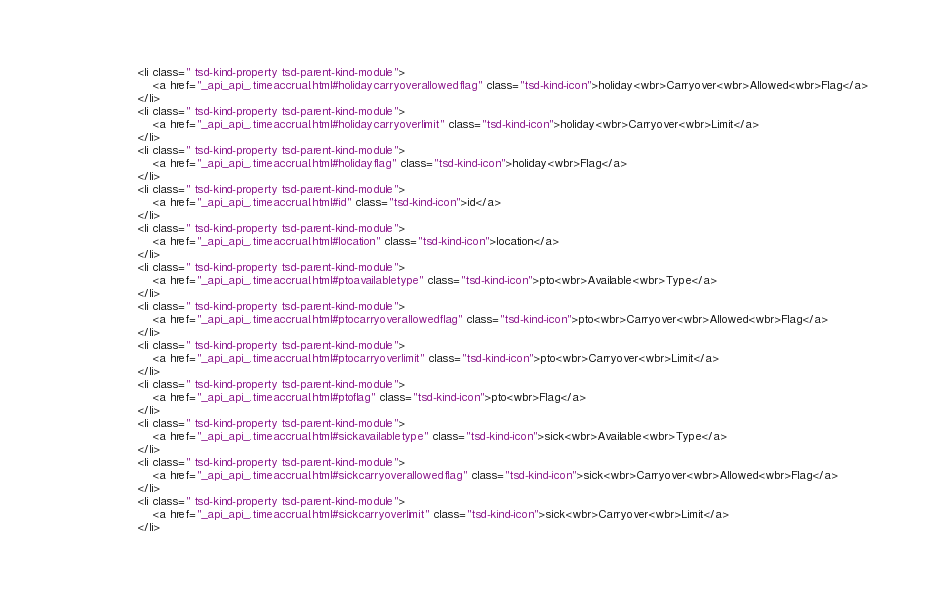Convert code to text. <code><loc_0><loc_0><loc_500><loc_500><_HTML_>					<li class=" tsd-kind-property tsd-parent-kind-module">
						<a href="_api_api_.timeaccrual.html#holidaycarryoverallowedflag" class="tsd-kind-icon">holiday<wbr>Carryover<wbr>Allowed<wbr>Flag</a>
					</li>
					<li class=" tsd-kind-property tsd-parent-kind-module">
						<a href="_api_api_.timeaccrual.html#holidaycarryoverlimit" class="tsd-kind-icon">holiday<wbr>Carryover<wbr>Limit</a>
					</li>
					<li class=" tsd-kind-property tsd-parent-kind-module">
						<a href="_api_api_.timeaccrual.html#holidayflag" class="tsd-kind-icon">holiday<wbr>Flag</a>
					</li>
					<li class=" tsd-kind-property tsd-parent-kind-module">
						<a href="_api_api_.timeaccrual.html#id" class="tsd-kind-icon">id</a>
					</li>
					<li class=" tsd-kind-property tsd-parent-kind-module">
						<a href="_api_api_.timeaccrual.html#location" class="tsd-kind-icon">location</a>
					</li>
					<li class=" tsd-kind-property tsd-parent-kind-module">
						<a href="_api_api_.timeaccrual.html#ptoavailabletype" class="tsd-kind-icon">pto<wbr>Available<wbr>Type</a>
					</li>
					<li class=" tsd-kind-property tsd-parent-kind-module">
						<a href="_api_api_.timeaccrual.html#ptocarryoverallowedflag" class="tsd-kind-icon">pto<wbr>Carryover<wbr>Allowed<wbr>Flag</a>
					</li>
					<li class=" tsd-kind-property tsd-parent-kind-module">
						<a href="_api_api_.timeaccrual.html#ptocarryoverlimit" class="tsd-kind-icon">pto<wbr>Carryover<wbr>Limit</a>
					</li>
					<li class=" tsd-kind-property tsd-parent-kind-module">
						<a href="_api_api_.timeaccrual.html#ptoflag" class="tsd-kind-icon">pto<wbr>Flag</a>
					</li>
					<li class=" tsd-kind-property tsd-parent-kind-module">
						<a href="_api_api_.timeaccrual.html#sickavailabletype" class="tsd-kind-icon">sick<wbr>Available<wbr>Type</a>
					</li>
					<li class=" tsd-kind-property tsd-parent-kind-module">
						<a href="_api_api_.timeaccrual.html#sickcarryoverallowedflag" class="tsd-kind-icon">sick<wbr>Carryover<wbr>Allowed<wbr>Flag</a>
					</li>
					<li class=" tsd-kind-property tsd-parent-kind-module">
						<a href="_api_api_.timeaccrual.html#sickcarryoverlimit" class="tsd-kind-icon">sick<wbr>Carryover<wbr>Limit</a>
					</li></code> 